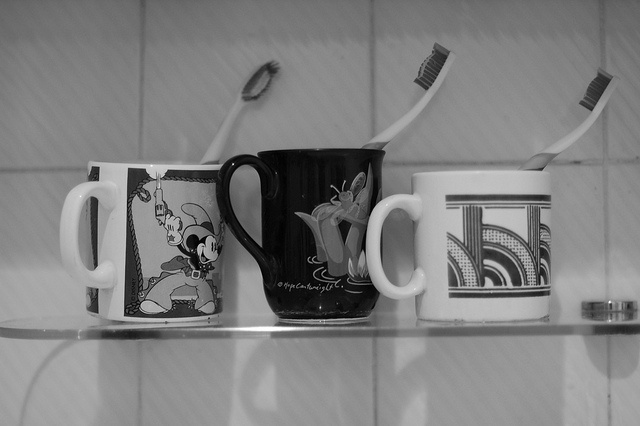Describe the objects in this image and their specific colors. I can see cup in gray, darkgray, black, and lightgray tones, cup in gray, darkgray, black, and lightgray tones, cup in gray, black, and lightgray tones, toothbrush in gray, black, and darkgray tones, and toothbrush in gray, black, and darkgray tones in this image. 